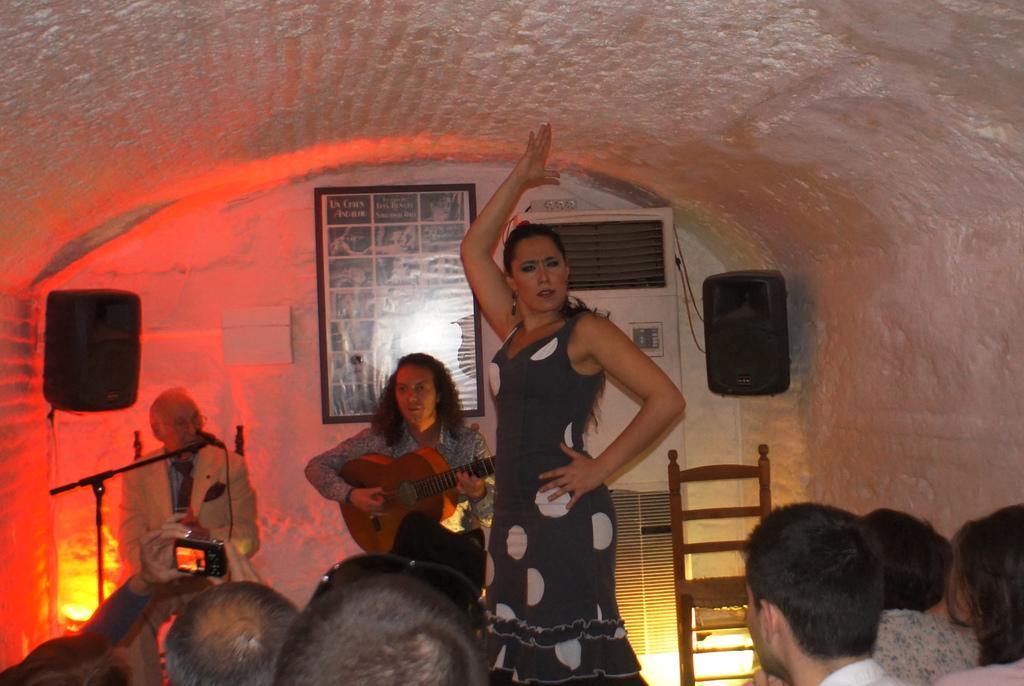Could you give a brief overview of what you see in this image? There are 2 playing guitar and a woman is dancing. People are looking at them. 